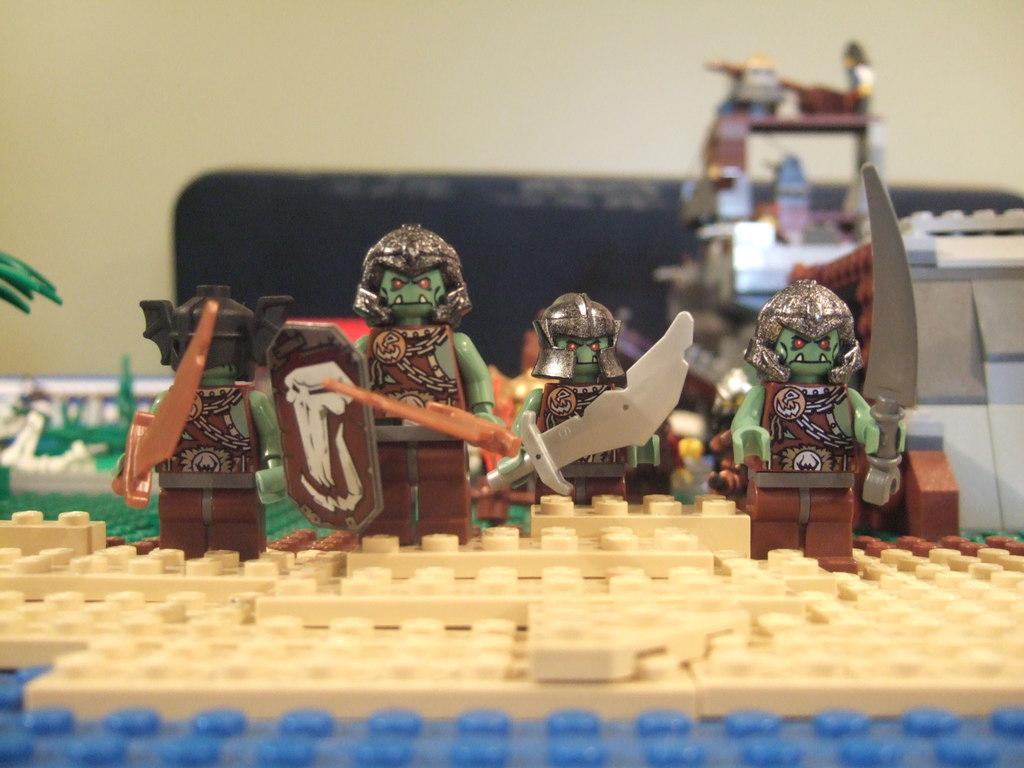What is the main subject of the image? The main subject of the image is a puzzle surface. What is placed on the puzzle surface? There are dolls on the puzzle surface. Can you describe the background of the image? The visibility of objects placed near the wall in the background is unclear. What type of boot can be seen in the alley in the image? There is no boot or alley present in the image; it features a puzzle surface with dolls and an unclear background. 